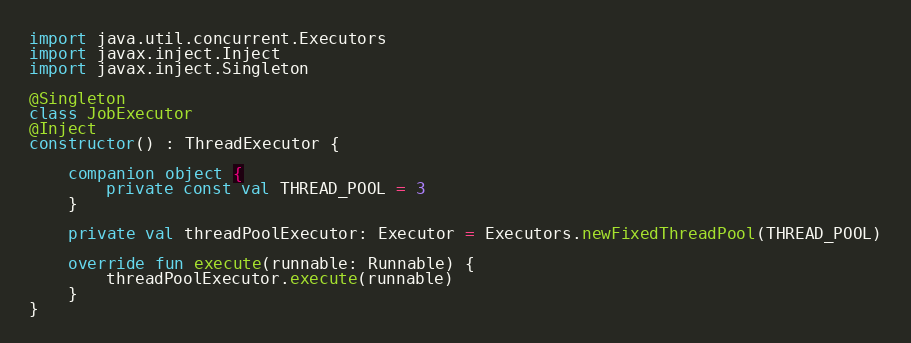<code> <loc_0><loc_0><loc_500><loc_500><_Kotlin_>import java.util.concurrent.Executors
import javax.inject.Inject
import javax.inject.Singleton

@Singleton
class JobExecutor
@Inject
constructor() : ThreadExecutor {

    companion object {
        private const val THREAD_POOL = 3
    }

    private val threadPoolExecutor: Executor = Executors.newFixedThreadPool(THREAD_POOL)

    override fun execute(runnable: Runnable) {
        threadPoolExecutor.execute(runnable)
    }
}
</code> 